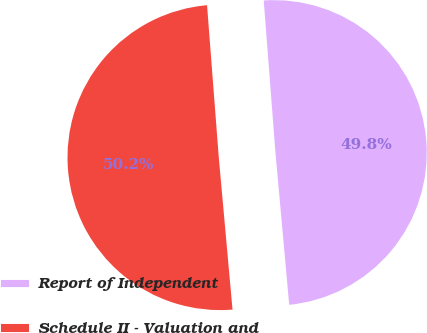<chart> <loc_0><loc_0><loc_500><loc_500><pie_chart><fcel>Report of Independent<fcel>Schedule II - Valuation and<nl><fcel>49.79%<fcel>50.21%<nl></chart> 